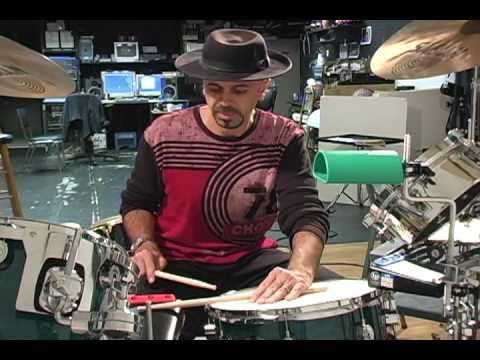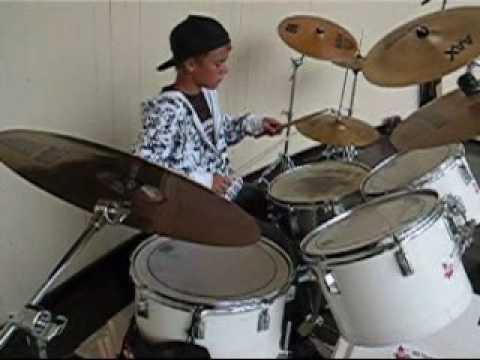The first image is the image on the left, the second image is the image on the right. Considering the images on both sides, is "In at least one image there are at least two cymboles and one red drum." valid? Answer yes or no. No. The first image is the image on the left, the second image is the image on the right. For the images shown, is this caption "At least one image includes a hand holding a drum stick over the flat top of a drum." true? Answer yes or no. Yes. 